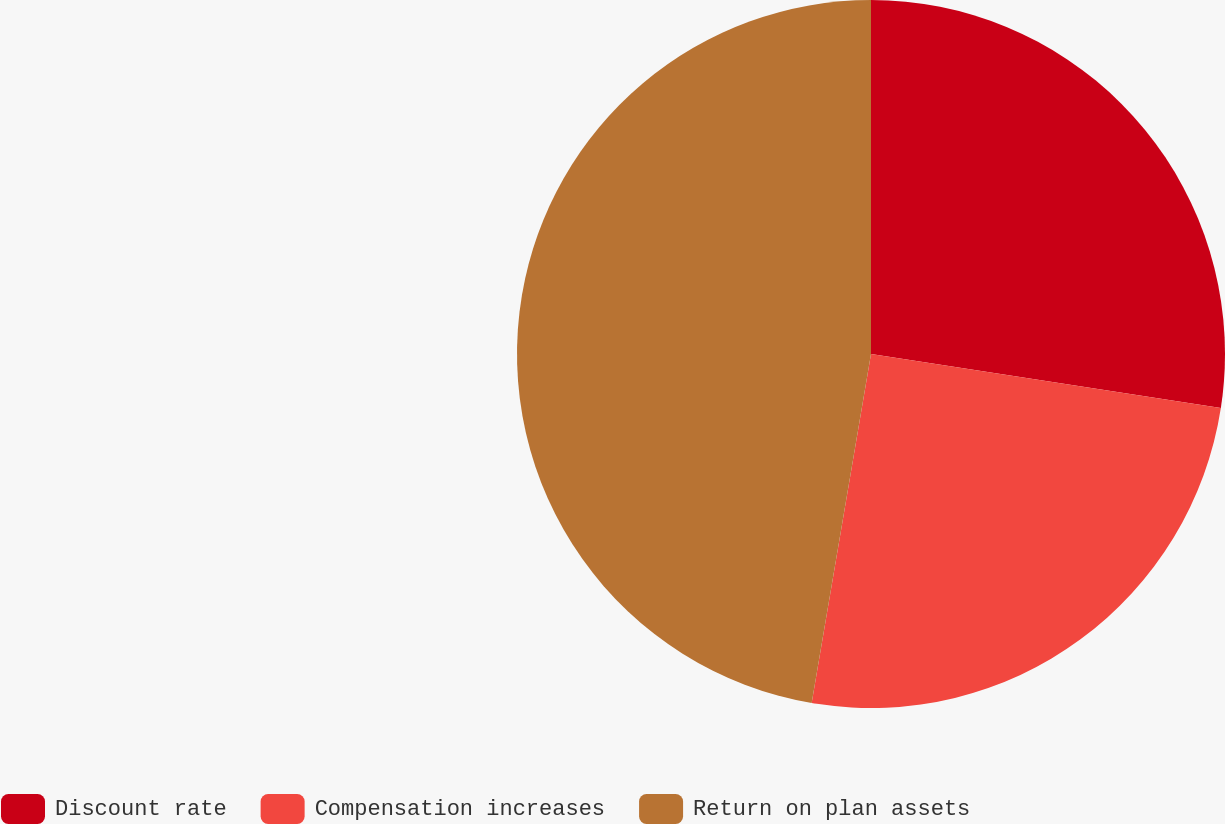Convert chart to OTSL. <chart><loc_0><loc_0><loc_500><loc_500><pie_chart><fcel>Discount rate<fcel>Compensation increases<fcel>Return on plan assets<nl><fcel>27.44%<fcel>25.24%<fcel>47.32%<nl></chart> 